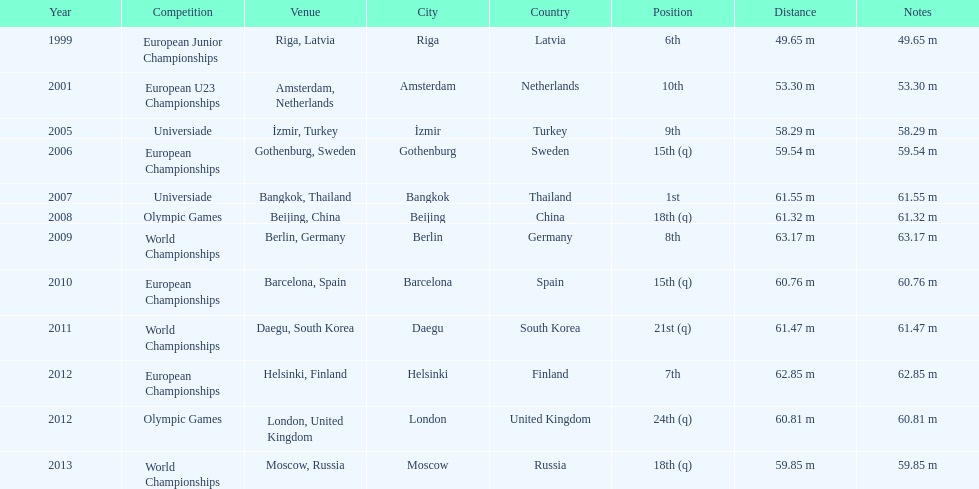Prior to 2007, what was the highest place achieved? 6th. 